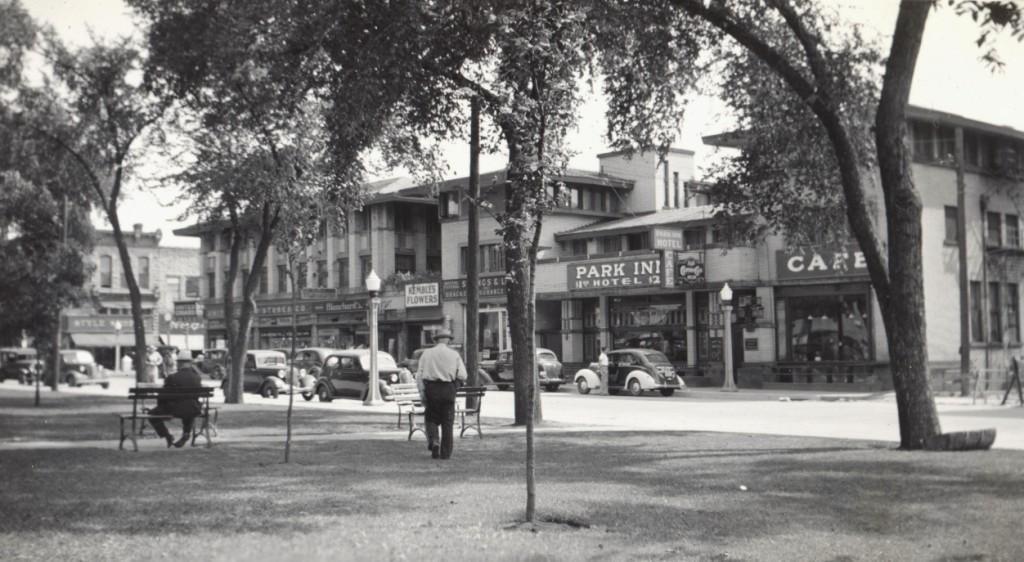Could you give a brief overview of what you see in this image? In the picture I can see people walking on the ground. In the background I can see the sky, buildings, vehicles, benches and other objects. This picture is black and white in color. 